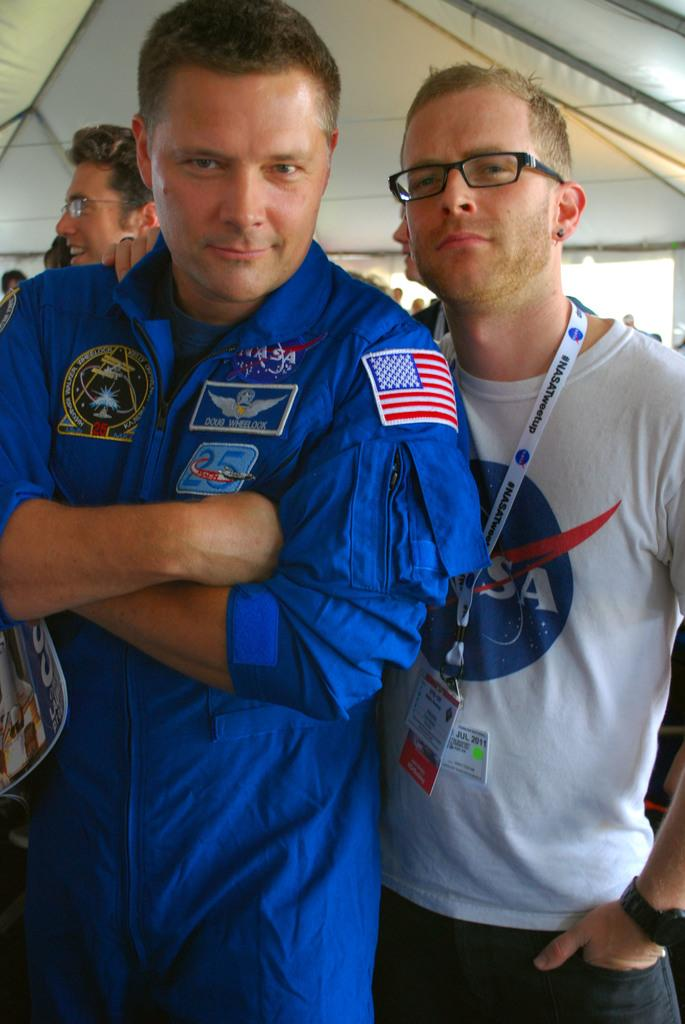What is the main subject of the image? The main subject of the image is a group of people. Can you describe any specific features of the people in the group? Two persons in the group are wearing spectacles. How many clams are visible in the image? There are no clams present in the image. What type of goose can be seen interacting with the people in the image? There is no goose present in the image; it only features a group of people. 